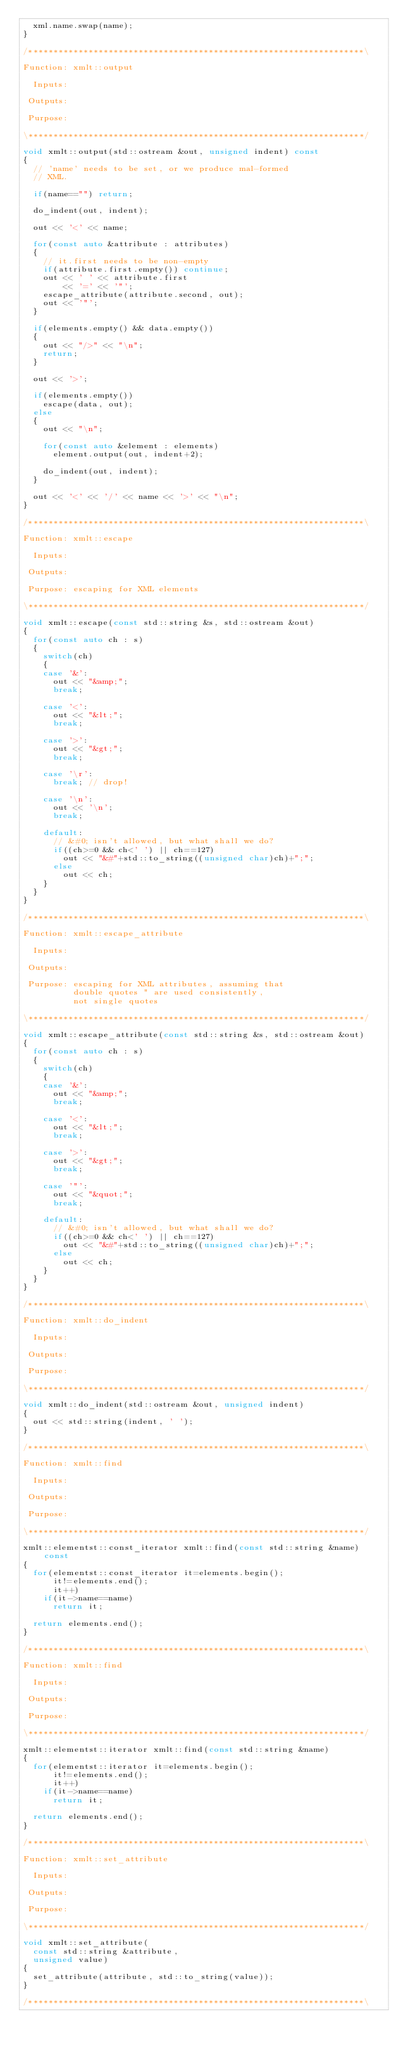<code> <loc_0><loc_0><loc_500><loc_500><_C++_>  xml.name.swap(name);
}

/*******************************************************************\

Function: xmlt::output

  Inputs:

 Outputs:

 Purpose:

\*******************************************************************/

void xmlt::output(std::ostream &out, unsigned indent) const
{
  // 'name' needs to be set, or we produce mal-formed
  // XML.

  if(name=="") return;

  do_indent(out, indent);

  out << '<' << name;

  for(const auto &attribute : attributes)
  {
    // it.first needs to be non-empty
    if(attribute.first.empty()) continue;
    out << ' ' << attribute.first
        << '=' << '"';
    escape_attribute(attribute.second, out);
    out << '"';
  }

  if(elements.empty() && data.empty())
  {
    out << "/>" << "\n";
    return;
  }

  out << '>';

  if(elements.empty())
    escape(data, out);
  else
  {
    out << "\n";

    for(const auto &element : elements)
      element.output(out, indent+2);

    do_indent(out, indent);
  }

  out << '<' << '/' << name << '>' << "\n";
}

/*******************************************************************\

Function: xmlt::escape

  Inputs:

 Outputs:

 Purpose: escaping for XML elements

\*******************************************************************/

void xmlt::escape(const std::string &s, std::ostream &out)
{
  for(const auto ch : s)
  {
    switch(ch)
    {
    case '&':
      out << "&amp;";
      break;

    case '<':
      out << "&lt;";
      break;

    case '>':
      out << "&gt;";
      break;

    case '\r':
      break; // drop!

    case '\n':
      out << '\n';
      break;

    default:
      // &#0; isn't allowed, but what shall we do?
      if((ch>=0 && ch<' ') || ch==127)
        out << "&#"+std::to_string((unsigned char)ch)+";";
      else
        out << ch;
    }
  }
}

/*******************************************************************\

Function: xmlt::escape_attribute

  Inputs:

 Outputs:

 Purpose: escaping for XML attributes, assuming that
          double quotes " are used consistently,
          not single quotes

\*******************************************************************/

void xmlt::escape_attribute(const std::string &s, std::ostream &out)
{
  for(const auto ch : s)
  {
    switch(ch)
    {
    case '&':
      out << "&amp;";
      break;

    case '<':
      out << "&lt;";
      break;

    case '>':
      out << "&gt;";
      break;

    case '"':
      out << "&quot;";
      break;

    default:
      // &#0; isn't allowed, but what shall we do?
      if((ch>=0 && ch<' ') || ch==127)
        out << "&#"+std::to_string((unsigned char)ch)+";";
      else
        out << ch;
    }
  }
}

/*******************************************************************\

Function: xmlt::do_indent

  Inputs:

 Outputs:

 Purpose:

\*******************************************************************/

void xmlt::do_indent(std::ostream &out, unsigned indent)
{
  out << std::string(indent, ' ');
}

/*******************************************************************\

Function: xmlt::find

  Inputs:

 Outputs:

 Purpose:

\*******************************************************************/

xmlt::elementst::const_iterator xmlt::find(const std::string &name) const
{
  for(elementst::const_iterator it=elements.begin();
      it!=elements.end();
      it++)
    if(it->name==name)
      return it;

  return elements.end();
}

/*******************************************************************\

Function: xmlt::find

  Inputs:

 Outputs:

 Purpose:

\*******************************************************************/

xmlt::elementst::iterator xmlt::find(const std::string &name)
{
  for(elementst::iterator it=elements.begin();
      it!=elements.end();
      it++)
    if(it->name==name)
      return it;

  return elements.end();
}

/*******************************************************************\

Function: xmlt::set_attribute

  Inputs:

 Outputs:

 Purpose:

\*******************************************************************/

void xmlt::set_attribute(
  const std::string &attribute,
  unsigned value)
{
  set_attribute(attribute, std::to_string(value));
}

/*******************************************************************\
</code> 